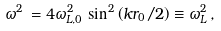<formula> <loc_0><loc_0><loc_500><loc_500>\omega ^ { 2 } \, = 4 \omega _ { L , 0 } ^ { 2 } \, \sin ^ { 2 } \left ( { k r _ { 0 } } / { 2 } \right ) \equiv \omega _ { L } ^ { 2 } \, ,</formula> 